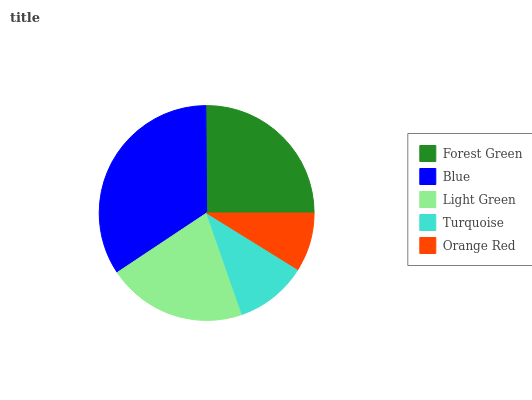Is Orange Red the minimum?
Answer yes or no. Yes. Is Blue the maximum?
Answer yes or no. Yes. Is Light Green the minimum?
Answer yes or no. No. Is Light Green the maximum?
Answer yes or no. No. Is Blue greater than Light Green?
Answer yes or no. Yes. Is Light Green less than Blue?
Answer yes or no. Yes. Is Light Green greater than Blue?
Answer yes or no. No. Is Blue less than Light Green?
Answer yes or no. No. Is Light Green the high median?
Answer yes or no. Yes. Is Light Green the low median?
Answer yes or no. Yes. Is Orange Red the high median?
Answer yes or no. No. Is Forest Green the low median?
Answer yes or no. No. 